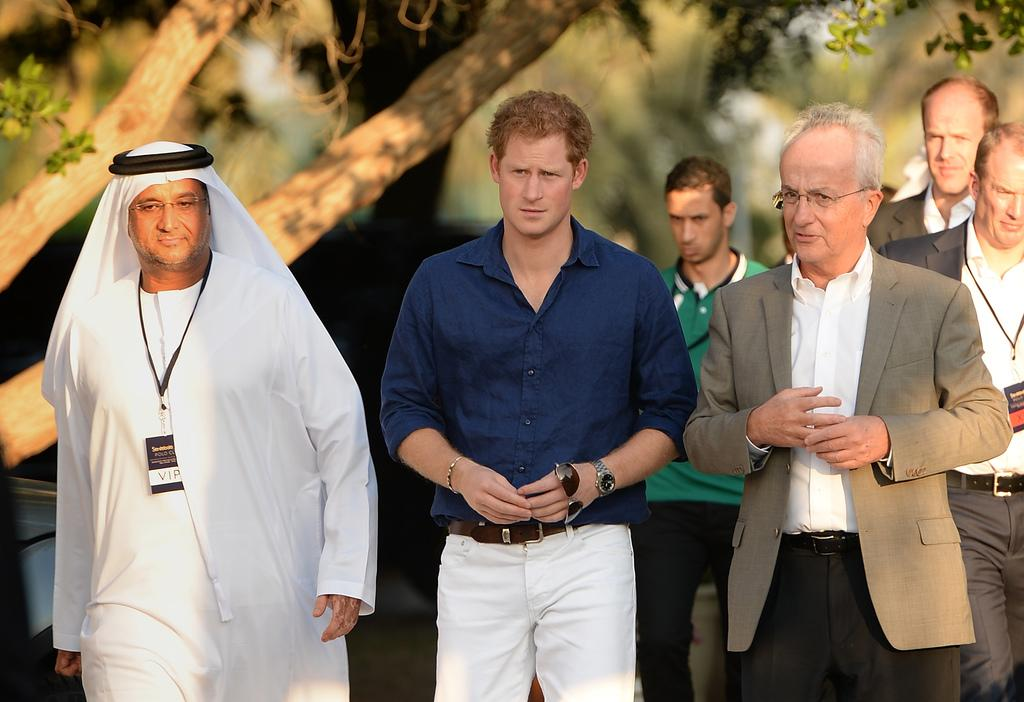What are the people in the image doing? The people in the image are walking. How can you describe the clothing of the people in the image? The people are wearing different color dresses. What type of natural environment can be seen in the image? There are trees visible in the image. Can you describe the background of the image? The background of the image is blurred. How many feet are on fire in the image? There are no feet on fire in the image; it does not depict any burning or flames. 